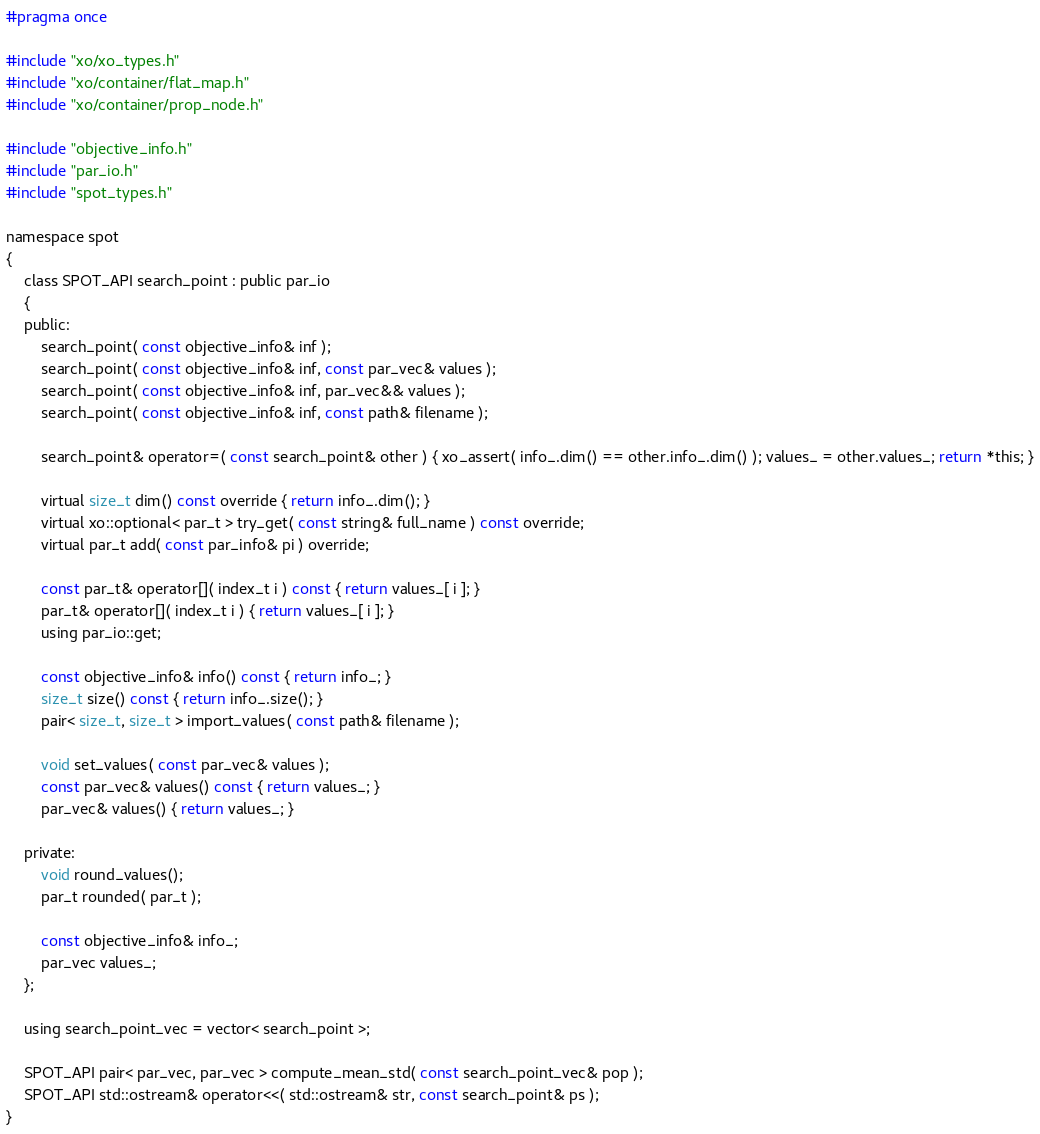<code> <loc_0><loc_0><loc_500><loc_500><_C_>#pragma once

#include "xo/xo_types.h"
#include "xo/container/flat_map.h"
#include "xo/container/prop_node.h"

#include "objective_info.h"
#include "par_io.h"
#include "spot_types.h"

namespace spot
{
	class SPOT_API search_point : public par_io
	{
	public:
		search_point( const objective_info& inf );
		search_point( const objective_info& inf, const par_vec& values );
		search_point( const objective_info& inf, par_vec&& values );
		search_point( const objective_info& inf, const path& filename );

		search_point& operator=( const search_point& other ) { xo_assert( info_.dim() == other.info_.dim() ); values_ = other.values_; return *this; }

		virtual size_t dim() const override { return info_.dim(); }
		virtual xo::optional< par_t > try_get( const string& full_name ) const override;
		virtual par_t add( const par_info& pi ) override;

		const par_t& operator[]( index_t i ) const { return values_[ i ]; }
		par_t& operator[]( index_t i ) { return values_[ i ]; }
		using par_io::get;

		const objective_info& info() const { return info_; }
		size_t size() const { return info_.size(); }
		pair< size_t, size_t > import_values( const path& filename );

		void set_values( const par_vec& values );
		const par_vec& values() const { return values_; }
		par_vec& values() { return values_; }

	private:
		void round_values();
		par_t rounded( par_t );

		const objective_info& info_;
		par_vec values_;
	};

	using search_point_vec = vector< search_point >;

	SPOT_API pair< par_vec, par_vec > compute_mean_std( const search_point_vec& pop );
	SPOT_API std::ostream& operator<<( std::ostream& str, const search_point& ps );
}
</code> 